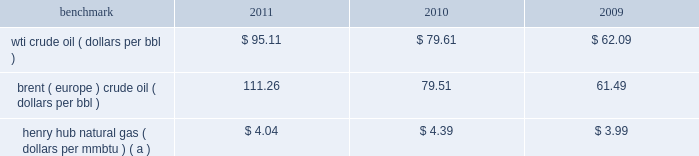Item 7 .
Management 2019s discussion and analysis of financial condition and results of operations we are an international energy company with operations in the u.s. , canada , africa , the middle east and europe .
Our operations are organized into three reportable segments : 2022 e&p which explores for , produces and markets liquid hydrocarbons and natural gas on a worldwide basis .
2022 osm which mines , extracts and transports bitumen from oil sands deposits in alberta , canada , and upgrades the bitumen to produce and market synthetic crude oil and vacuum gas oil .
2022 ig which produces and markets products manufactured from natural gas , such as lng and methanol , in eg .
Certain sections of management 2019s discussion and analysis of financial condition and results of operations include forward-looking statements concerning trends or events potentially affecting our business .
These statements typically contain words such as 201canticipates , 201d 201cbelieves , 201d 201cestimates , 201d 201cexpects , 201d 201ctargets , 201d 201cplans , 201d 201cprojects , 201d 201ccould , 201d 201cmay , 201d 201cshould , 201d 201cwould 201d or similar words indicating that future outcomes are uncertain .
In accordance with 201csafe harbor 201d provisions of the private securities litigation reform act of 1995 , these statements are accompanied by cautionary language identifying important factors , though not necessarily all such factors , which could cause future outcomes to differ materially from those set forth in forward-looking statements .
For additional risk factors affecting our business , see item 1a .
Risk factors in this annual report on form 10-k .
Management 2019s discussion and analysis of financial condition and results of operations should be read in conjunction with the information under item 1 .
Business , item 1a .
Risk factors and item 8 .
Financial statements and supplementary data found in this annual report on form 10-k .
Spin-off downstream business on june 30 , 2011 , the spin-off of marathon 2019s downstream business was completed , creating two independent energy companies : marathon oil and mpc .
Marathon shareholders at the close of business on the record date of june 27 , 2011 received one share of mpc common stock for every two shares of marathon common stock held .
Fractional shares of mpc common stock were not distributed and any fractional share of mpc common stock otherwise issuable to a marathon shareholder was sold in the open market on such shareholder 2019s behalf , and such shareholder received a cash payment with respect to that fractional share .
A private letter tax ruling received in june 2011 from the irs affirmed the tax-free nature of the spin-off .
Activities related to the downstream business have been treated as discontinued operations in all periods presented in this annual report on form 10-k ( see item 8 .
Financial statements and supplementary data 2014note 3 to the consolidated financial statements for additional information ) .
Overview 2013 market conditions exploration and production prevailing prices for the various grades of crude oil and natural gas that we produce significantly impact our revenues and cash flows .
Prices of crude oil have been volatile in recent years .
In 2011 , crude prices increased over 2010 levels , with increases in brent averages outstripping those in wti .
During much of 2010 , both wti and brent crude oil monthly average prices remained in the $ 75 to $ 85 per barrel range .
Crude oil prices reached a low of $ 33.98 in february 2009 , following global demand declines in an economic recession , but recovered quickly ending 2009 at $ 79.36 .
The table lists benchmark crude oil and natural gas price annual averages for the past three years. .
Wti crude oil ( dollars per bbl ) $ 95.11 $ 79.61 $ 62.09 brent ( europe ) crude oil ( dollars per bbl ) 111.26 79.51 61.49 henry hub natural gas ( dollars per mmbtu ) ( a ) $ 4.04 $ 4.39 $ 3.99 ( a ) settlement date average .
Our u.s .
Crude oil production was approximately 58 percent sour in 2011 and 68 percent in 2010 .
Sour crude contains more sulfur than light sweet wti does .
Sour crude oil also tends to be heavier than light sweet crude oil and sells at a discount to light sweet crude oil because of higher refining costs and lower refined product values .
Our international crude oil production is relatively sweet and is generally sold in relation to the brent crude benchmark .
The differential between wti and brent average prices widened significantly in 2011 to $ 16.15 in comparison to differentials of less than $ 1.00 in 2010 and 2009. .
What was the approximate differential between wti and brent average prices in 2011 in comparison to differentials in 2010 and 2009? 
Computations: (16.15 - 1.00)
Answer: 15.15. 